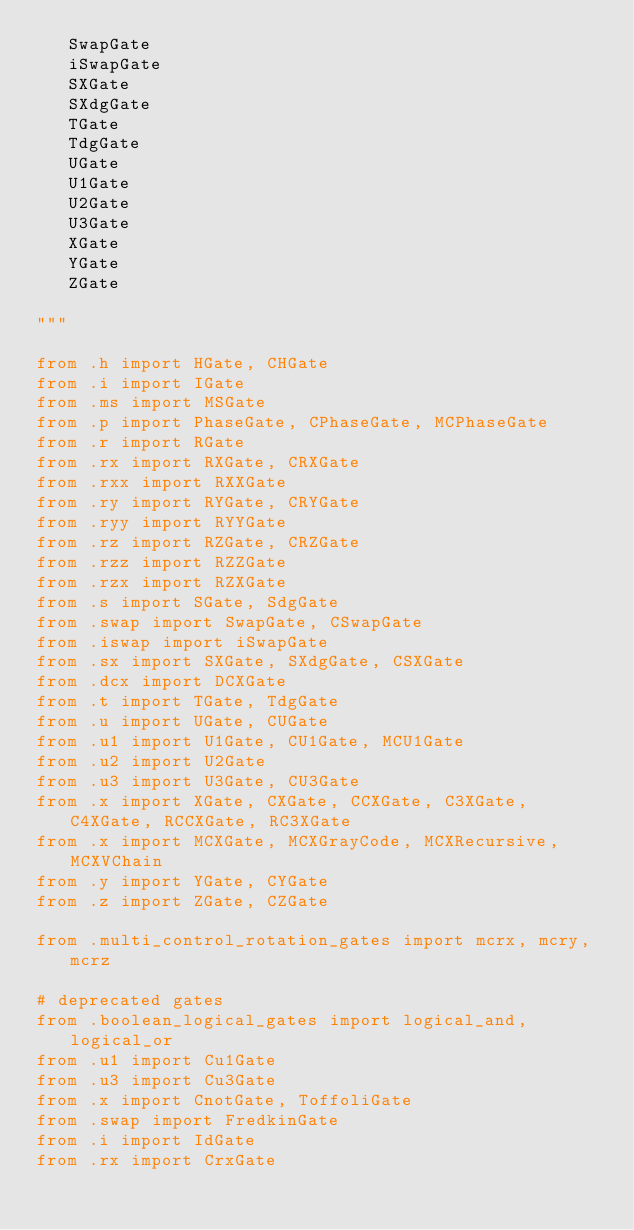Convert code to text. <code><loc_0><loc_0><loc_500><loc_500><_Python_>   SwapGate
   iSwapGate
   SXGate
   SXdgGate
   TGate
   TdgGate
   UGate
   U1Gate
   U2Gate
   U3Gate
   XGate
   YGate
   ZGate

"""

from .h import HGate, CHGate
from .i import IGate
from .ms import MSGate
from .p import PhaseGate, CPhaseGate, MCPhaseGate
from .r import RGate
from .rx import RXGate, CRXGate
from .rxx import RXXGate
from .ry import RYGate, CRYGate
from .ryy import RYYGate
from .rz import RZGate, CRZGate
from .rzz import RZZGate
from .rzx import RZXGate
from .s import SGate, SdgGate
from .swap import SwapGate, CSwapGate
from .iswap import iSwapGate
from .sx import SXGate, SXdgGate, CSXGate
from .dcx import DCXGate
from .t import TGate, TdgGate
from .u import UGate, CUGate
from .u1 import U1Gate, CU1Gate, MCU1Gate
from .u2 import U2Gate
from .u3 import U3Gate, CU3Gate
from .x import XGate, CXGate, CCXGate, C3XGate, C4XGate, RCCXGate, RC3XGate
from .x import MCXGate, MCXGrayCode, MCXRecursive, MCXVChain
from .y import YGate, CYGate
from .z import ZGate, CZGate

from .multi_control_rotation_gates import mcrx, mcry, mcrz

# deprecated gates
from .boolean_logical_gates import logical_and, logical_or
from .u1 import Cu1Gate
from .u3 import Cu3Gate
from .x import CnotGate, ToffoliGate
from .swap import FredkinGate
from .i import IdGate
from .rx import CrxGate</code> 